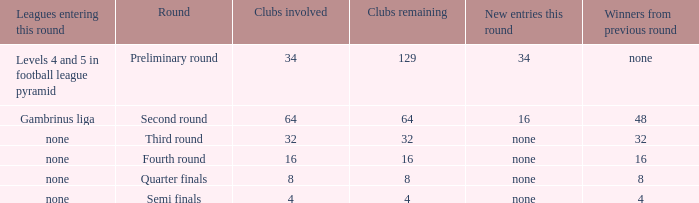Name the leagues entering this round for 4 None. 